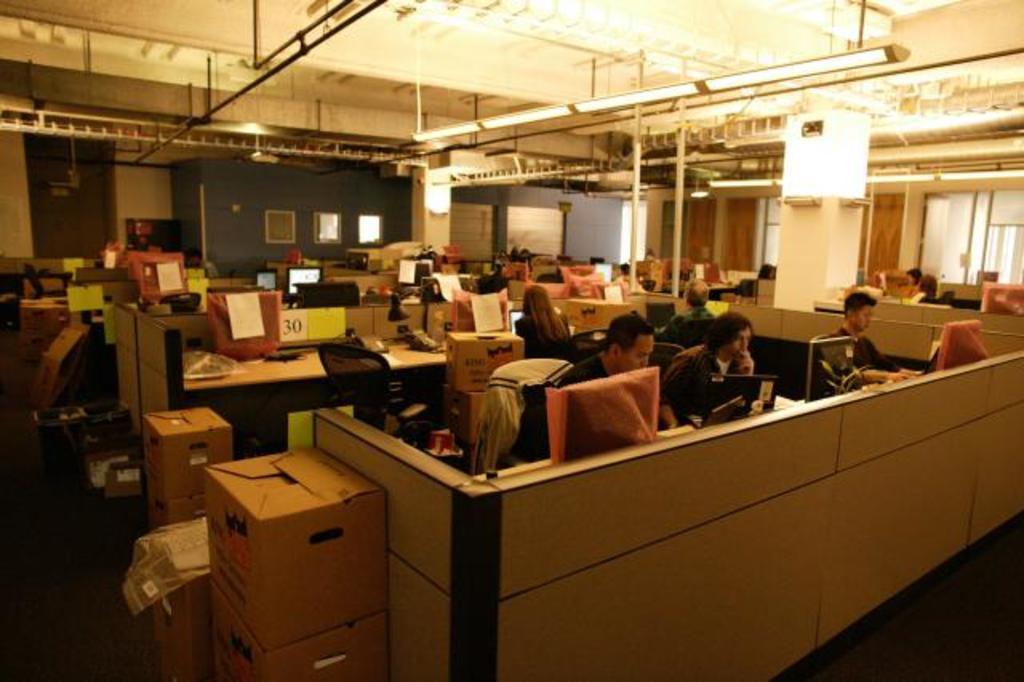How would you summarize this image in a sentence or two? In this image, we can see some persons, cabins and boxes. There are lights hanging from the ceiling which is at the top of the image. There is a pillar on the right side of the image. 